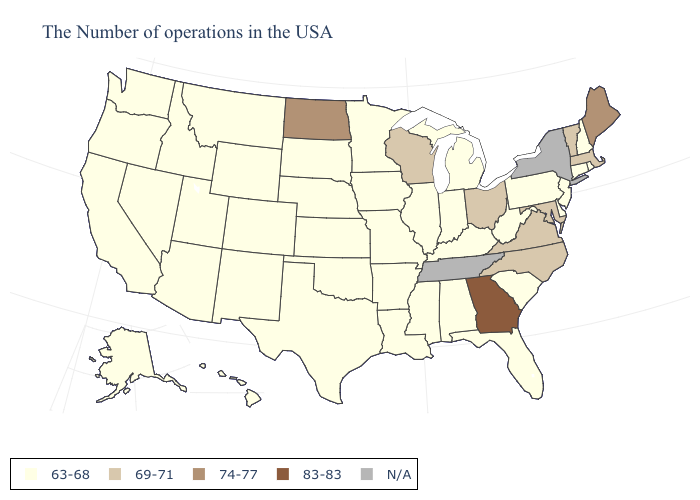Name the states that have a value in the range 63-68?
Be succinct. Rhode Island, New Hampshire, Connecticut, New Jersey, Delaware, Pennsylvania, South Carolina, West Virginia, Florida, Michigan, Kentucky, Indiana, Alabama, Illinois, Mississippi, Louisiana, Missouri, Arkansas, Minnesota, Iowa, Kansas, Nebraska, Oklahoma, Texas, South Dakota, Wyoming, Colorado, New Mexico, Utah, Montana, Arizona, Idaho, Nevada, California, Washington, Oregon, Alaska, Hawaii. What is the value of New Jersey?
Concise answer only. 63-68. Does Massachusetts have the lowest value in the USA?
Write a very short answer. No. Among the states that border Tennessee , which have the highest value?
Quick response, please. Georgia. Name the states that have a value in the range N/A?
Give a very brief answer. New York, Tennessee. What is the value of South Carolina?
Be succinct. 63-68. Among the states that border Mississippi , which have the lowest value?
Quick response, please. Alabama, Louisiana, Arkansas. Name the states that have a value in the range 74-77?
Give a very brief answer. Maine, North Dakota. What is the value of New Hampshire?
Write a very short answer. 63-68. What is the value of Minnesota?
Answer briefly. 63-68. Among the states that border Tennessee , which have the highest value?
Keep it brief. Georgia. Which states have the highest value in the USA?
Be succinct. Georgia. What is the value of Rhode Island?
Be succinct. 63-68. Does the first symbol in the legend represent the smallest category?
Answer briefly. Yes. 